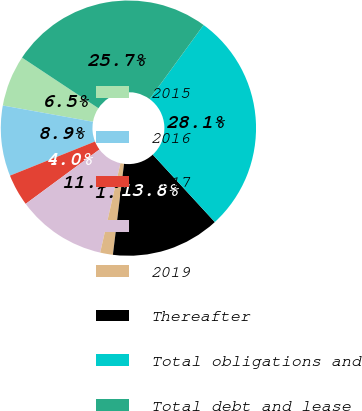<chart> <loc_0><loc_0><loc_500><loc_500><pie_chart><fcel>2015<fcel>2016<fcel>2017<fcel>2018<fcel>2019<fcel>Thereafter<fcel>Total obligations and<fcel>Total debt and lease<nl><fcel>6.48%<fcel>8.91%<fcel>4.04%<fcel>11.34%<fcel>1.61%<fcel>13.78%<fcel>28.14%<fcel>25.71%<nl></chart> 